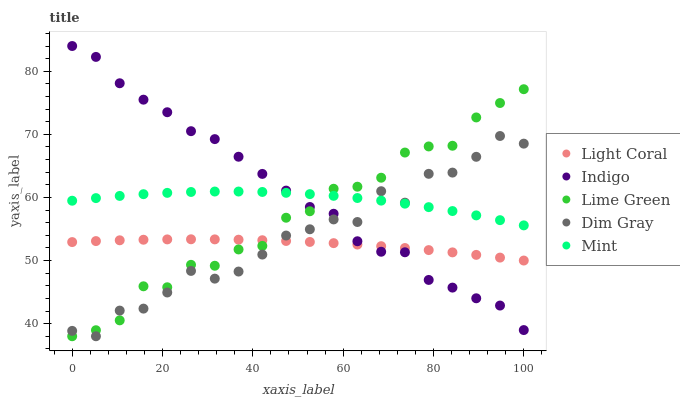Does Light Coral have the minimum area under the curve?
Answer yes or no. Yes. Does Indigo have the maximum area under the curve?
Answer yes or no. Yes. Does Lime Green have the minimum area under the curve?
Answer yes or no. No. Does Lime Green have the maximum area under the curve?
Answer yes or no. No. Is Light Coral the smoothest?
Answer yes or no. Yes. Is Dim Gray the roughest?
Answer yes or no. Yes. Is Lime Green the smoothest?
Answer yes or no. No. Is Lime Green the roughest?
Answer yes or no. No. Does Lime Green have the lowest value?
Answer yes or no. Yes. Does Indigo have the lowest value?
Answer yes or no. No. Does Indigo have the highest value?
Answer yes or no. Yes. Does Lime Green have the highest value?
Answer yes or no. No. Is Light Coral less than Mint?
Answer yes or no. Yes. Is Mint greater than Light Coral?
Answer yes or no. Yes. Does Lime Green intersect Indigo?
Answer yes or no. Yes. Is Lime Green less than Indigo?
Answer yes or no. No. Is Lime Green greater than Indigo?
Answer yes or no. No. Does Light Coral intersect Mint?
Answer yes or no. No. 